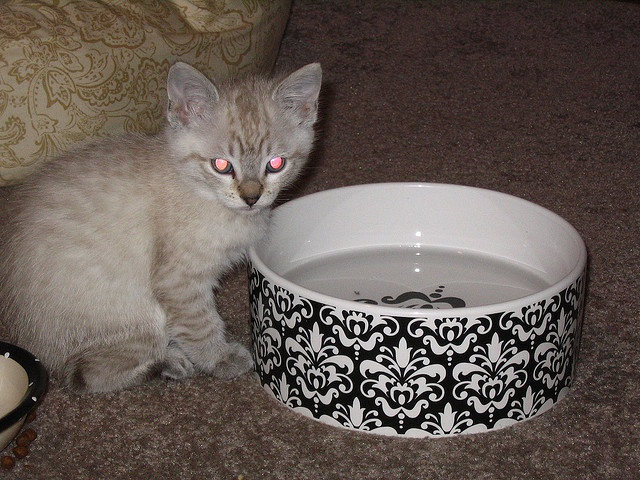Describe the objects in this image and their specific colors. I can see bowl in black, darkgray, lightgray, and gray tones, cat in black, darkgray, and gray tones, and bowl in black and gray tones in this image. 